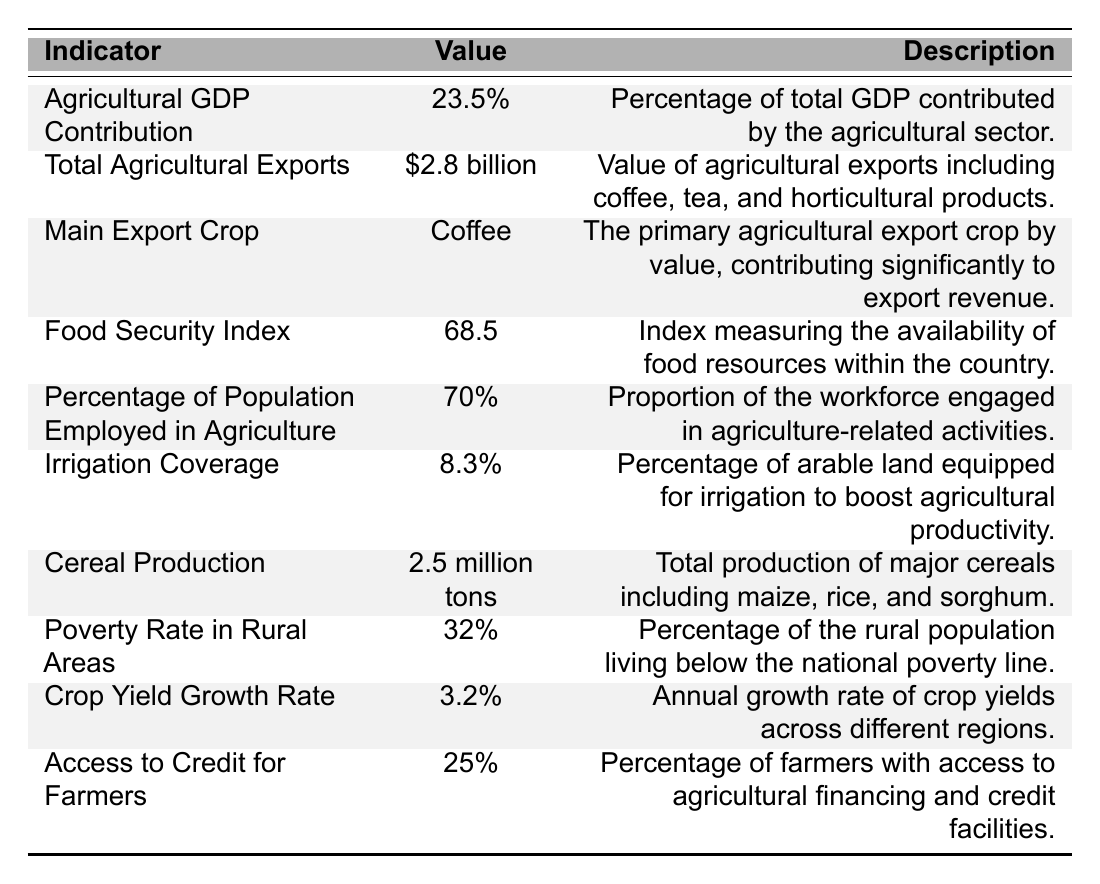What percentage of Uganda's GDP is contributed by the agricultural sector? The table indicates that the Agricultural GDP Contribution is 23.5%. Therefore, this percentage reflects the agricultural sector's contribution to the total GDP.
Answer: 23.5% What is the value of total agricultural exports from Uganda in 2022? According to the table, the Total Agricultural Exports are valued at $2.8 billion. This figure represents the monetary worth of agricultural products exported from Uganda.
Answer: $2.8 billion Which crop is identified as the main agricultural export crop in Uganda? The table states that Coffee is the Main Export Crop. This means it is the crop with the highest value in agricultural exports.
Answer: Coffee What is the Food Security Index value for Uganda in 2022? The Food Security Index is listed as 68.5 in the table. This index measures the availability of food resources in the country.
Answer: 68.5 How much of the population is employed in agriculture-related activities? The table shows that 70% of the population is employed in Agriculture. This indicates a significant portion of the workforce involved in the agricultural sector.
Answer: 70% What percentage of arable land in Uganda is equipped for irrigation? The table states that Irrigation Coverage is at 8.3%. This percentage denotes the amount of arable land that has irrigation facilities to enhance agricultural productivity.
Answer: 8.3% What is the total production of cereals reported for Uganda? According to the table, Cereal Production is noted as 2.5 million tons. This figure represents the total output of major cereal crops like maize, rice, and sorghum.
Answer: 2.5 million tons What percentage of the rural population lives below the national poverty line? The table reveals that the Poverty Rate in Rural Areas is 32%. This percentage reflects the portion of the rural population experiencing poverty.
Answer: 32% What is the yearly growth rate of crop yields in Uganda? The table indicates that the Crop Yield Growth Rate is 3.2%. This percentage shows the annual increase in crop yields across various regions in Uganda.
Answer: 3.2% How many farmers have access to agricultural financing and credit facilities? The data presents that 25% of farmers have Access to Credit for Farmers. This percentage shows the proportion of farmers who can access financial support for agricultural purposes.
Answer: 25% What is the relationship between the agricultural GDP contribution and the poverty rate in rural areas? The Agricultural GDP Contribution is 23.5% while the Poverty Rate in Rural Areas is 32%. A potential analysis could suggest that a significant portion of the rural population experiences poverty despite the agricultural sector's contribution to GDP, indicating potential inefficiencies or disparities in wealth distribution.
Answer: There is a disconnect; GDP is 23.5% but poverty rate is 32% How does the Food Security Index relate to the percentage of the population employed in agriculture? The Food Security Index is 68.5 while 70% of the population is employed in agriculture. This could imply that even with a high level of employment in agriculture, food security challenges still exist, as indicated by the index.
Answer: Employment doesn't ensure food security What is the difference in value between the total agricultural exports and the poverty rate in rural areas? The Total Agricultural Exports are $2.8 billion, and the Poverty Rate in Rural Areas is 32%. The values represent different measures (financial vs. social); however, one could discuss the disparity where financial exports might not translate into poverty alleviation for rural populations.
Answer: Not directly comparable Is the access to credit for farmers sufficient given the employment rate in agriculture? With 70% of the population employed in agriculture yet only 25% of farmers having access to credit, it suggests that many farmers may lack financial resources essential for productivity improvements, potentially impacting overall agricultural output.
Answer: Access is low compared to employment levels How can the irrigation coverage impact cereal production levels? The irrigation coverage is 8.3%, and cereal production is at 2.5 million tons. Low irrigation coverage may limit the ability to enhance production levels, as irrigation is vital for maintaining consistent water supply for crops.
Answer: Low irrigation may limit production 